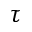Convert formula to latex. <formula><loc_0><loc_0><loc_500><loc_500>\tau</formula> 